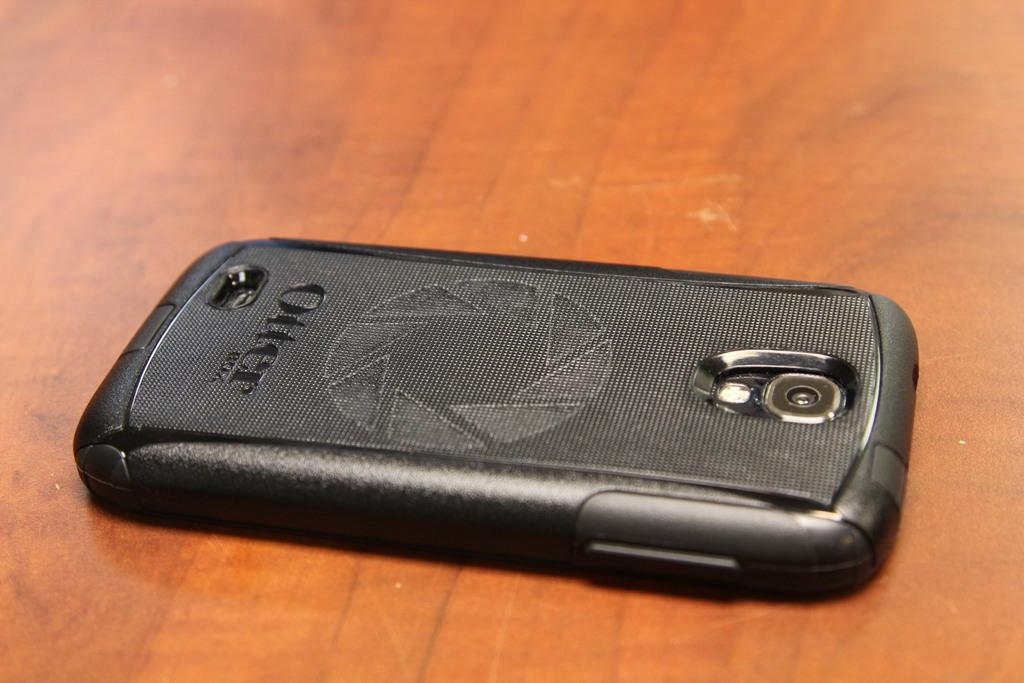<image>
Provide a brief description of the given image. cellphone with otter box cover on it laying on wooden surface 